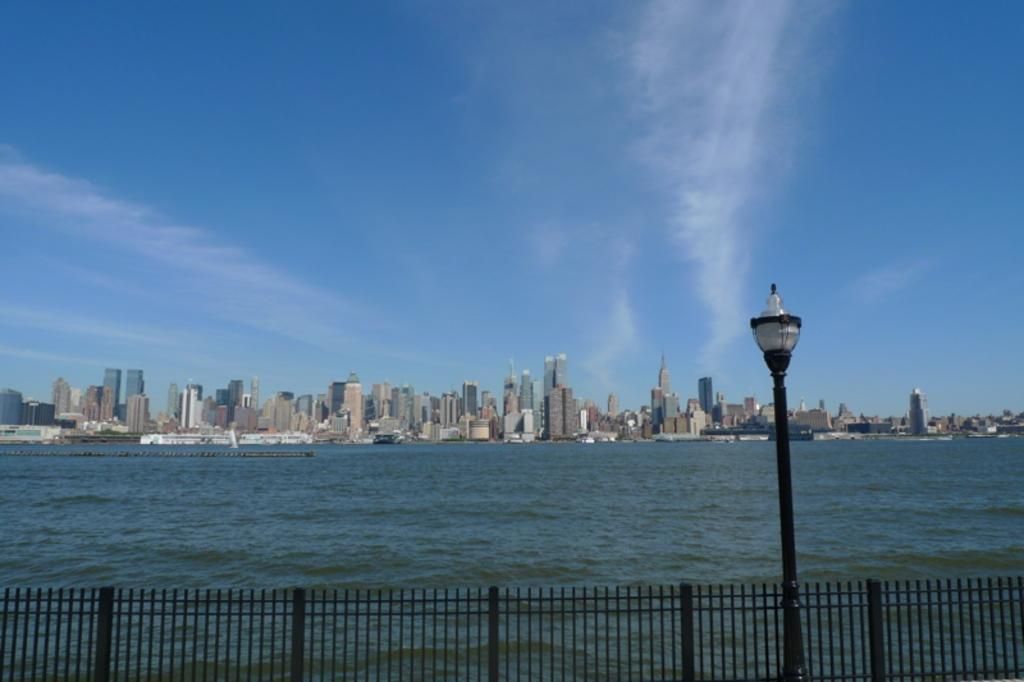What is the main feature of the image? There is a large water body in the image. What else can be seen in the image besides the water body? There is a group of buildings and towers in the image. What is the condition of the sky in the image? The sky appears cloudy in the image. What is present in the foreground of the image? There is a street pole in the foreground of the image. What type of quill is being used to write on the street pole in the image? There is no quill present in the image, and no writing activity is taking place on the street pole. 